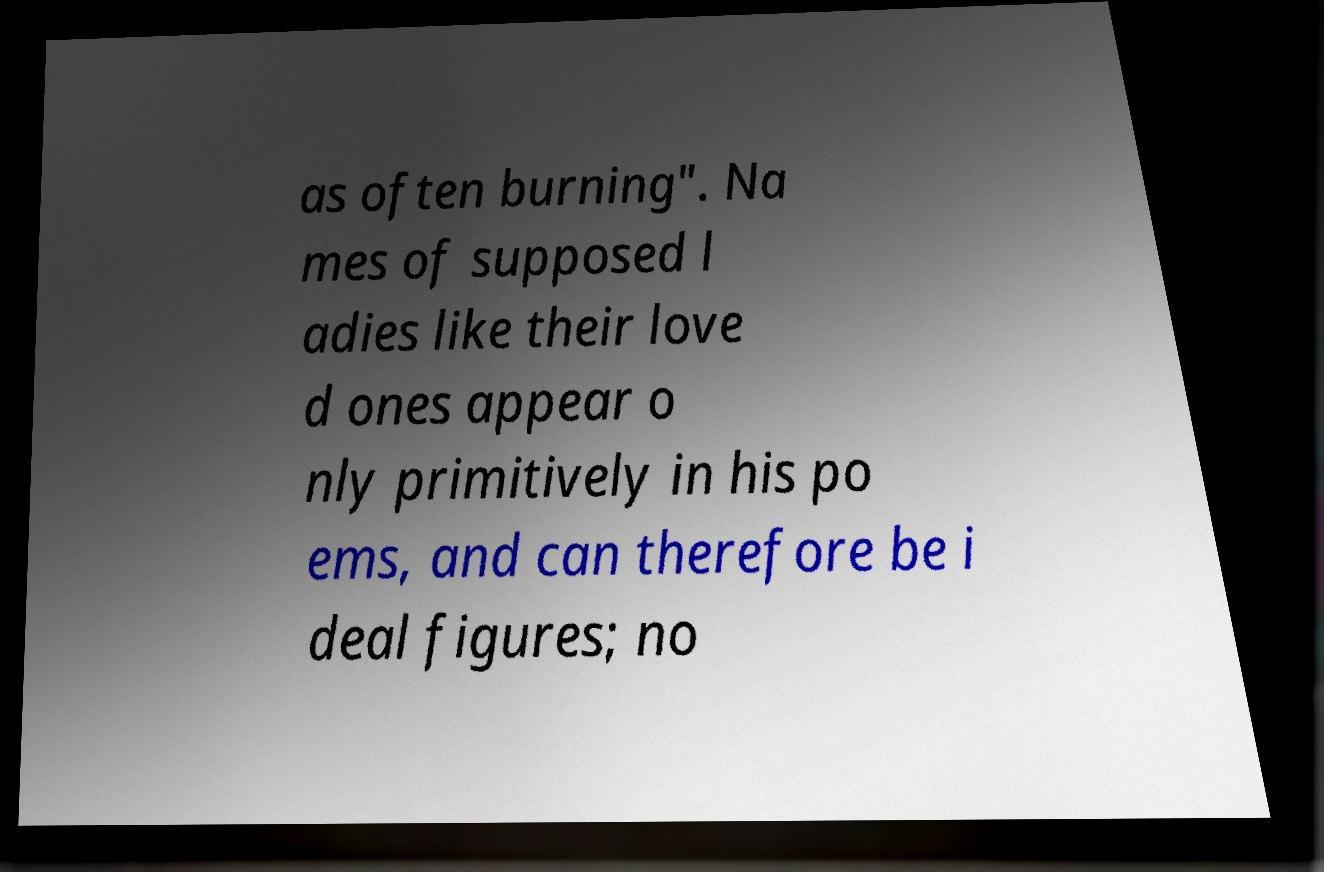There's text embedded in this image that I need extracted. Can you transcribe it verbatim? as often burning". Na mes of supposed l adies like their love d ones appear o nly primitively in his po ems, and can therefore be i deal figures; no 